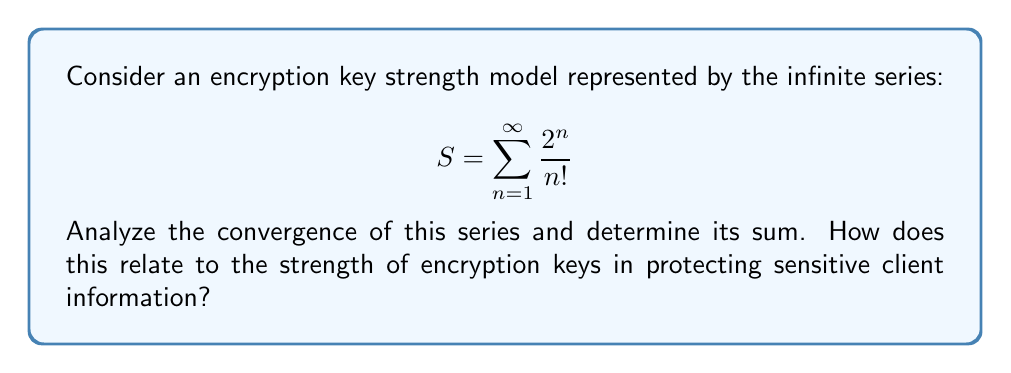Provide a solution to this math problem. To analyze the convergence of this series, we'll use the ratio test:

1) First, let's define the general term of the series:

   $$a_n = \frac{2^n}{n!}$$

2) Now, we'll calculate the limit of the ratio of consecutive terms:

   $$\lim_{n \to \infty} \left|\frac{a_{n+1}}{a_n}\right| = \lim_{n \to \infty} \left|\frac{2^{n+1}/(n+1)!}{2^n/n!}\right|$$

3) Simplify:

   $$= \lim_{n \to \infty} \left|\frac{2^{n+1}}{2^n} \cdot \frac{n!}{(n+1)!}\right| = \lim_{n \to \infty} \left|2 \cdot \frac{1}{n+1}\right|$$

4) Evaluate the limit:

   $$= 2 \cdot \lim_{n \to \infty} \frac{1}{n+1} = 0$$

5) Since the limit is less than 1, the series converges by the ratio test.

6) To find the sum, we can recognize this as the Taylor series for $e^x$ with $x=2$:

   $$e^x = \sum_{n=0}^{\infty} \frac{x^n}{n!}$$

7) Our series starts at $n=1$, so we need to subtract 1 from $e^2$:

   $$S = e^2 - 1$$

Interpretation for encryption key strength:
The convergence of this series to a finite value (approximately 6.389) could represent the upper limit of encryption key strength in a particular system. As we add more terms (increasing n), the contribution to the overall strength diminishes, similar to how increasing key length beyond a certain point provides diminishing returns in cryptographic security. This model suggests that there's a theoretical maximum to key strength, emphasizing the importance of choosing an appropriate key length that balances security and computational efficiency when protecting sensitive client information.
Answer: The series converges, and its sum is $S = e^2 - 1 \approx 6.389$. 